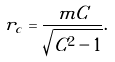<formula> <loc_0><loc_0><loc_500><loc_500>r _ { c } = \frac { m C } { \sqrt { C ^ { 2 } - 1 } } .</formula> 